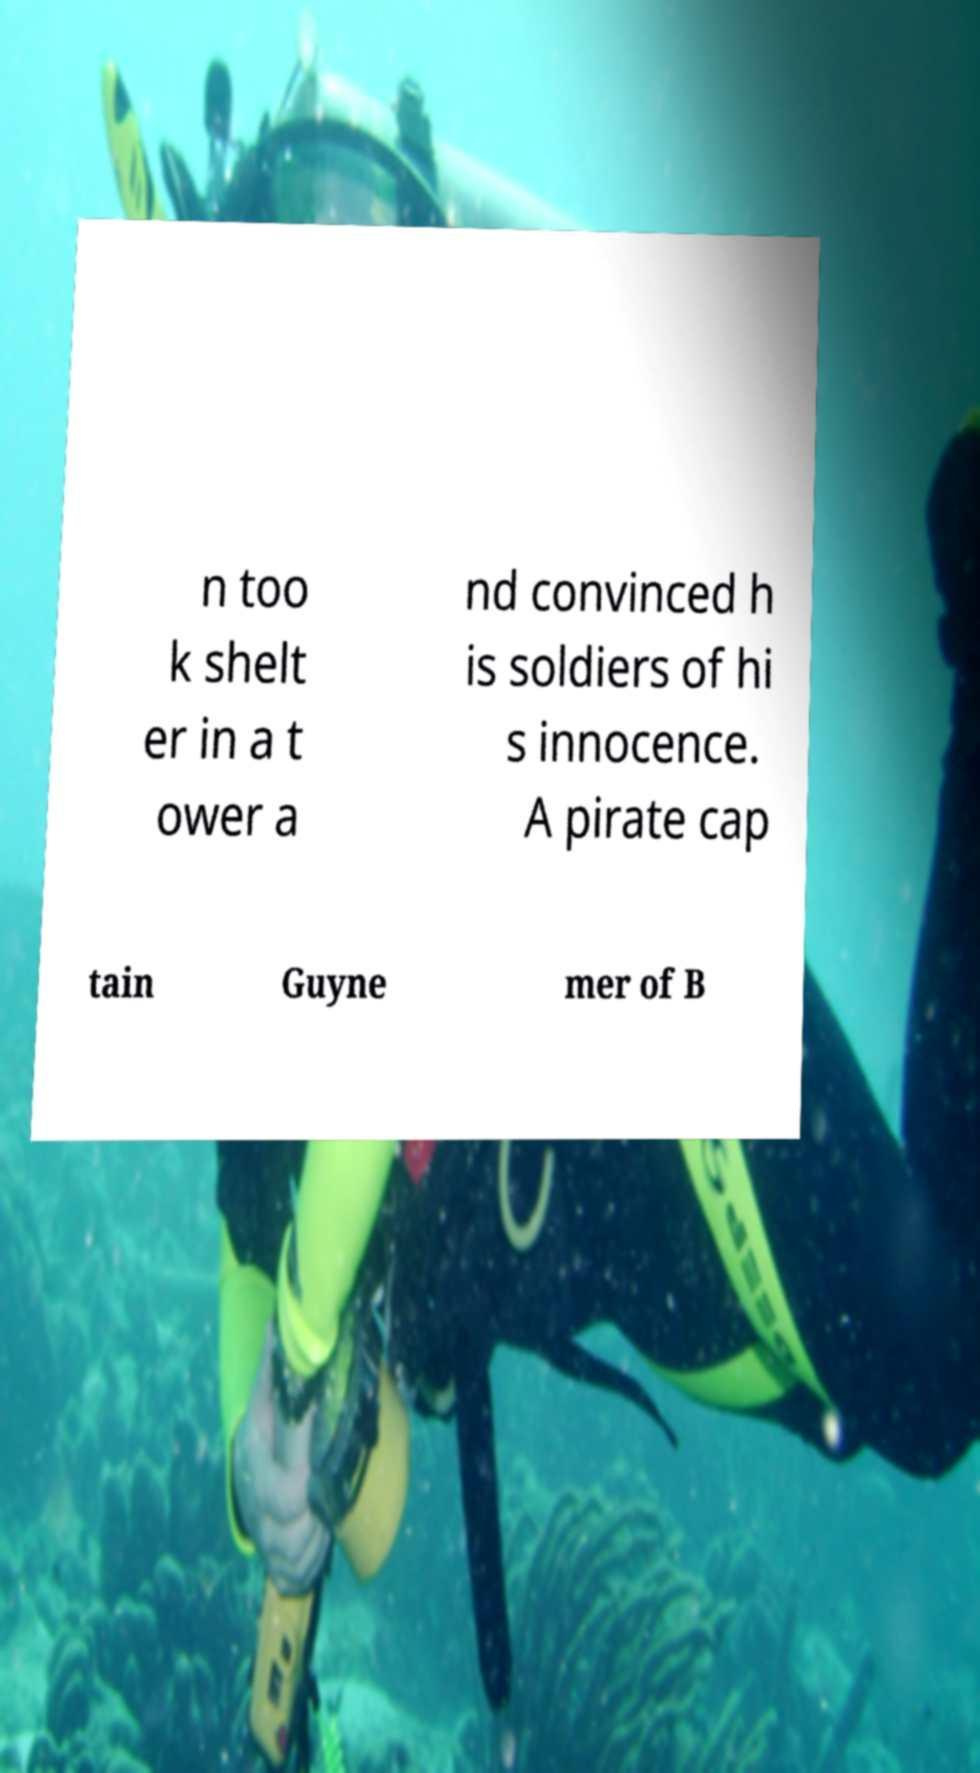Could you extract and type out the text from this image? n too k shelt er in a t ower a nd convinced h is soldiers of hi s innocence. A pirate cap tain Guyne mer of B 